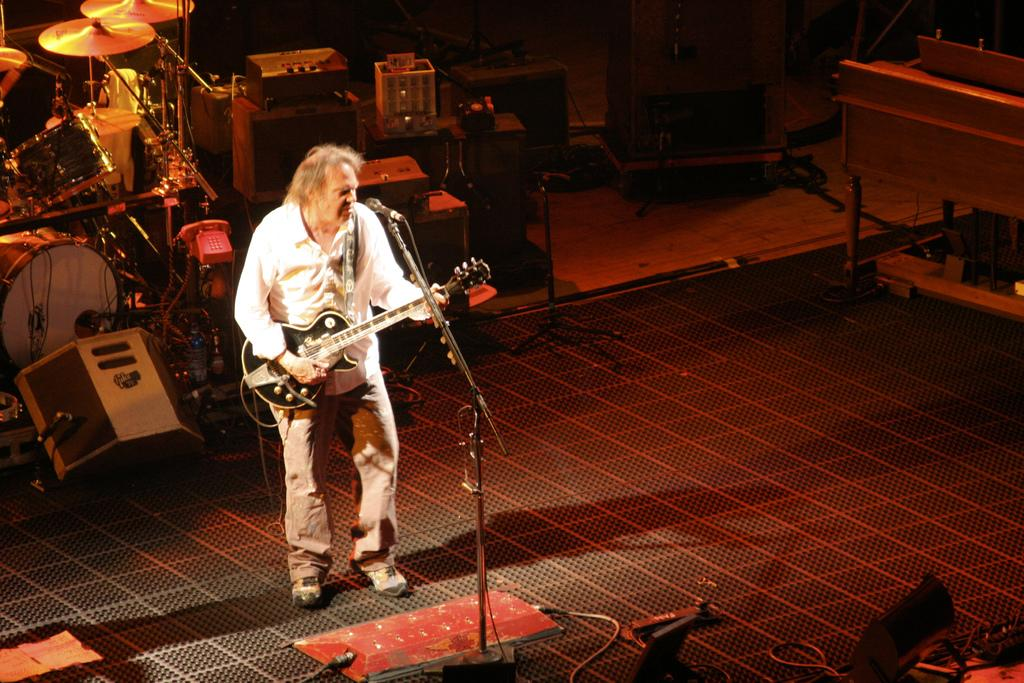Who is the main subject in the image? There is a man in the image. What is the man doing in the image? The man is playing a guitar. What object is in front of the man? There is a microphone in front of the man. How many beds can be seen in the image? There are no beds present in the image. Is the man in the image a spy? There is no indication in the image that the man is a spy. 